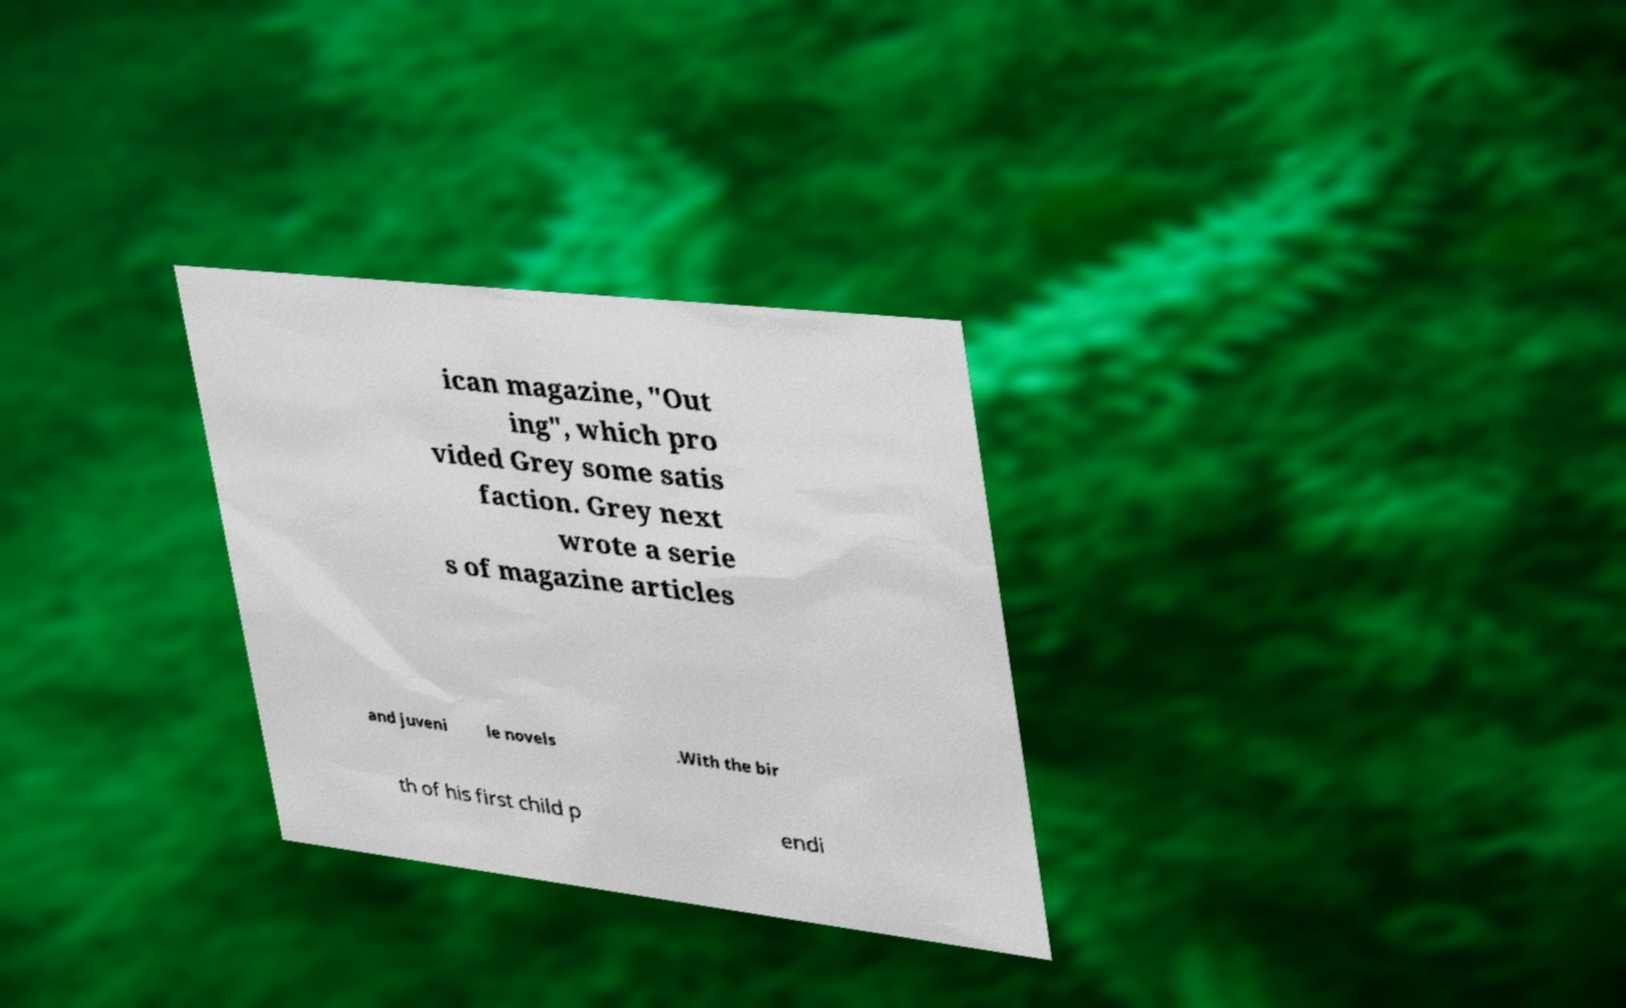Please identify and transcribe the text found in this image. ican magazine, "Out ing", which pro vided Grey some satis faction. Grey next wrote a serie s of magazine articles and juveni le novels .With the bir th of his first child p endi 